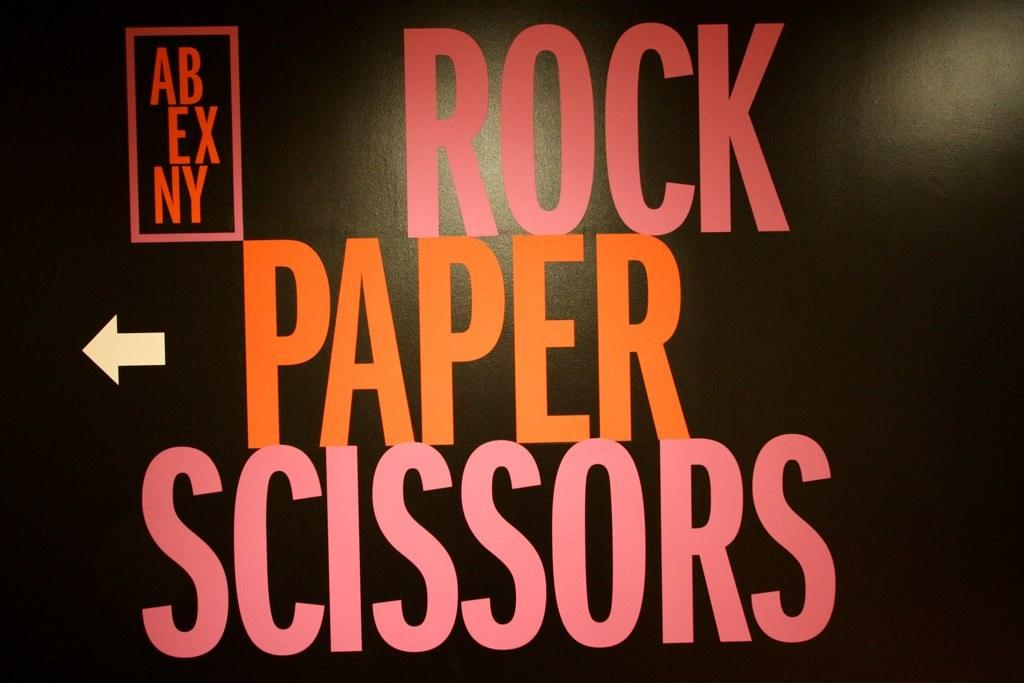<image>
Create a compact narrative representing the image presented. Black poster with Rock, Paper, Scissors written in bright letters on it. 